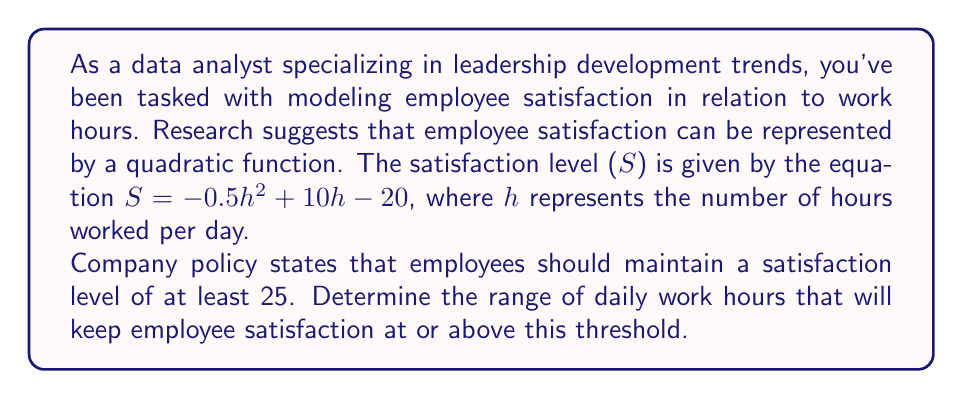What is the answer to this math problem? To solve this problem, we need to use a quadratic inequality. Let's approach this step-by-step:

1) The inequality we need to solve is:
   $S \geq 25$

2) Substituting the given function for S:
   $-0.5h^2 + 10h - 20 \geq 25$

3) Rearranging the inequality:
   $-0.5h^2 + 10h - 45 \geq 0$

4) Multiply all terms by -2 to make the coefficient of $h^2$ positive. Remember to flip the inequality sign when multiplying by a negative number:
   $h^2 - 20h + 90 \leq 0$

5) This is a quadratic inequality. To solve it, we first need to find the roots of the quadratic equation $h^2 - 20h + 90 = 0$

6) We can solve this using the quadratic formula: $h = \frac{-b \pm \sqrt{b^2 - 4ac}}{2a}$
   Where $a=1$, $b=-20$, and $c=90$

7) Solving:
   $h = \frac{20 \pm \sqrt{400 - 360}}{2} = \frac{20 \pm \sqrt{40}}{2} = \frac{20 \pm 2\sqrt{10}}{2}$

8) This gives us two roots:
   $h_1 = 10 + \sqrt{10} \approx 13.16$
   $h_2 = 10 - \sqrt{10} \approx 6.84$

9) For a quadratic inequality of the form $ah^2 + bh + c \leq 0$ where $a > 0$, the solution is all values of h between the two roots.

Therefore, employee satisfaction will be at least 25 when the number of daily work hours is between approximately 6.84 and 13.16 hours.
Answer: The range of daily work hours that will keep employee satisfaction at or above 25 is:

$10 - \sqrt{10} \leq h \leq 10 + \sqrt{10}$

or approximately:

$6.84 \leq h \leq 13.16$ 